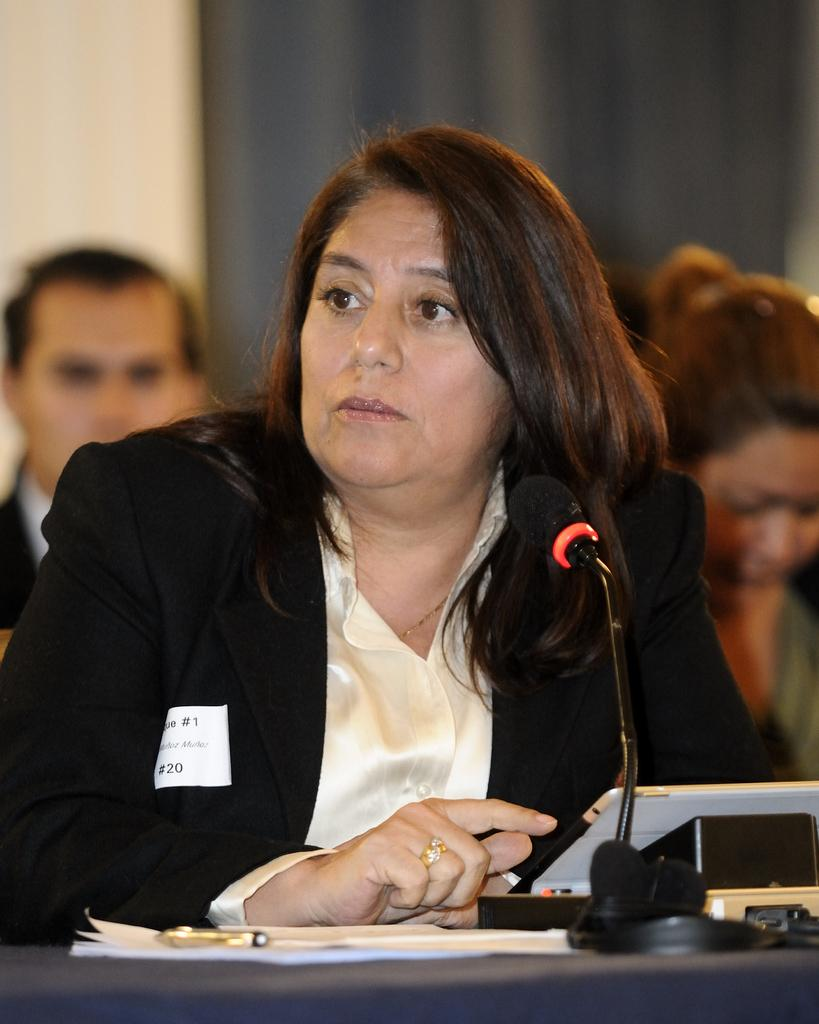What is the woman in the image doing? The woman is sitting in the image. What is in front of the woman? There is a book, a pen, and a microphone in front of the woman. What can be found on the table in the image? There are objects on the table in the image. What is visible in the background of the image? There are people and a wall in the background of the image. What type of fuel is being used to power the door in the image? There is no door present in the image, and therefore no fuel is being used to power it. 